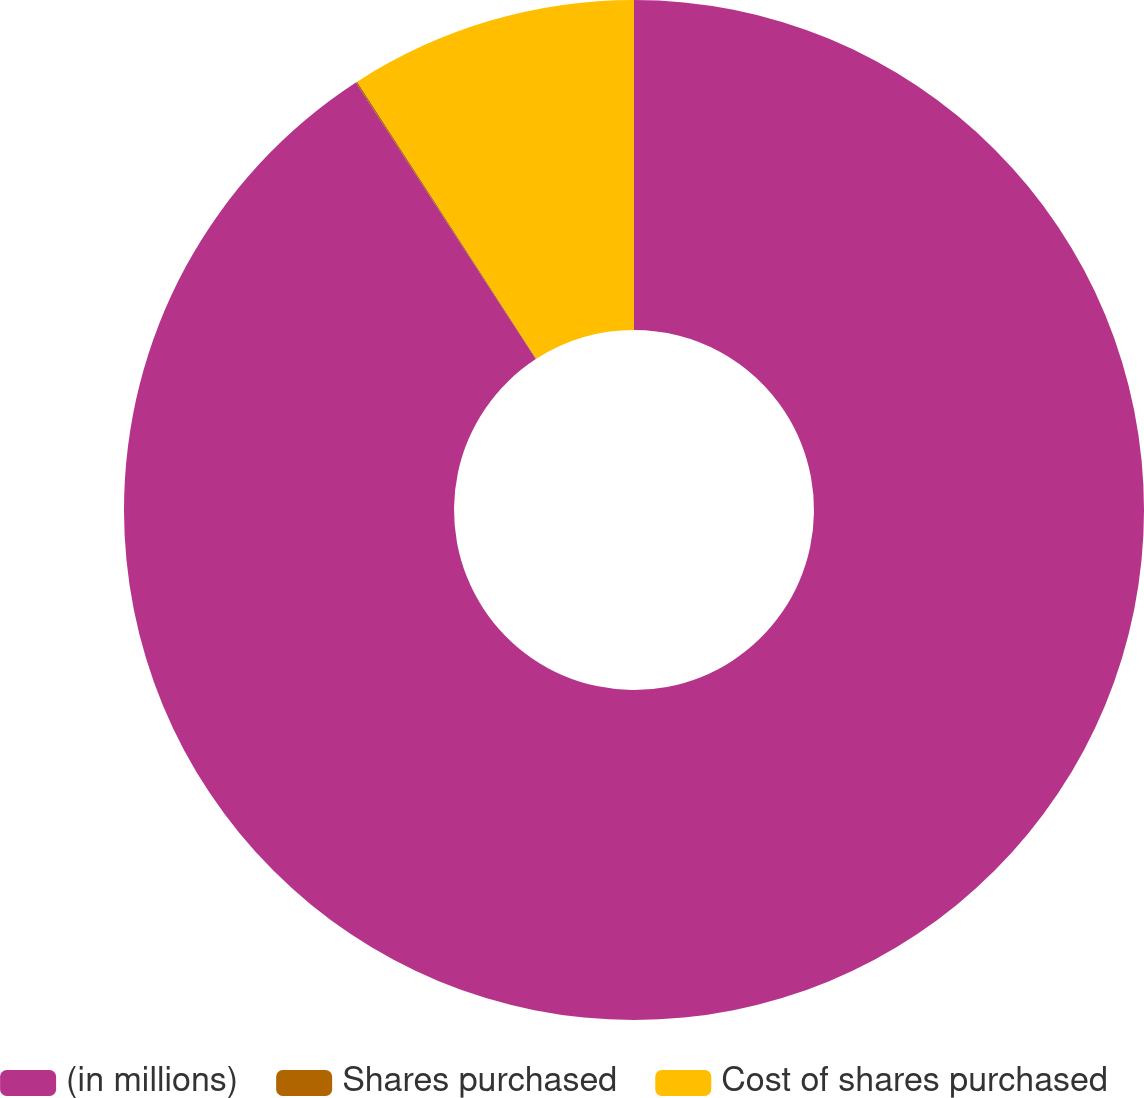<chart> <loc_0><loc_0><loc_500><loc_500><pie_chart><fcel>(in millions)<fcel>Shares purchased<fcel>Cost of shares purchased<nl><fcel>90.82%<fcel>0.05%<fcel>9.13%<nl></chart> 